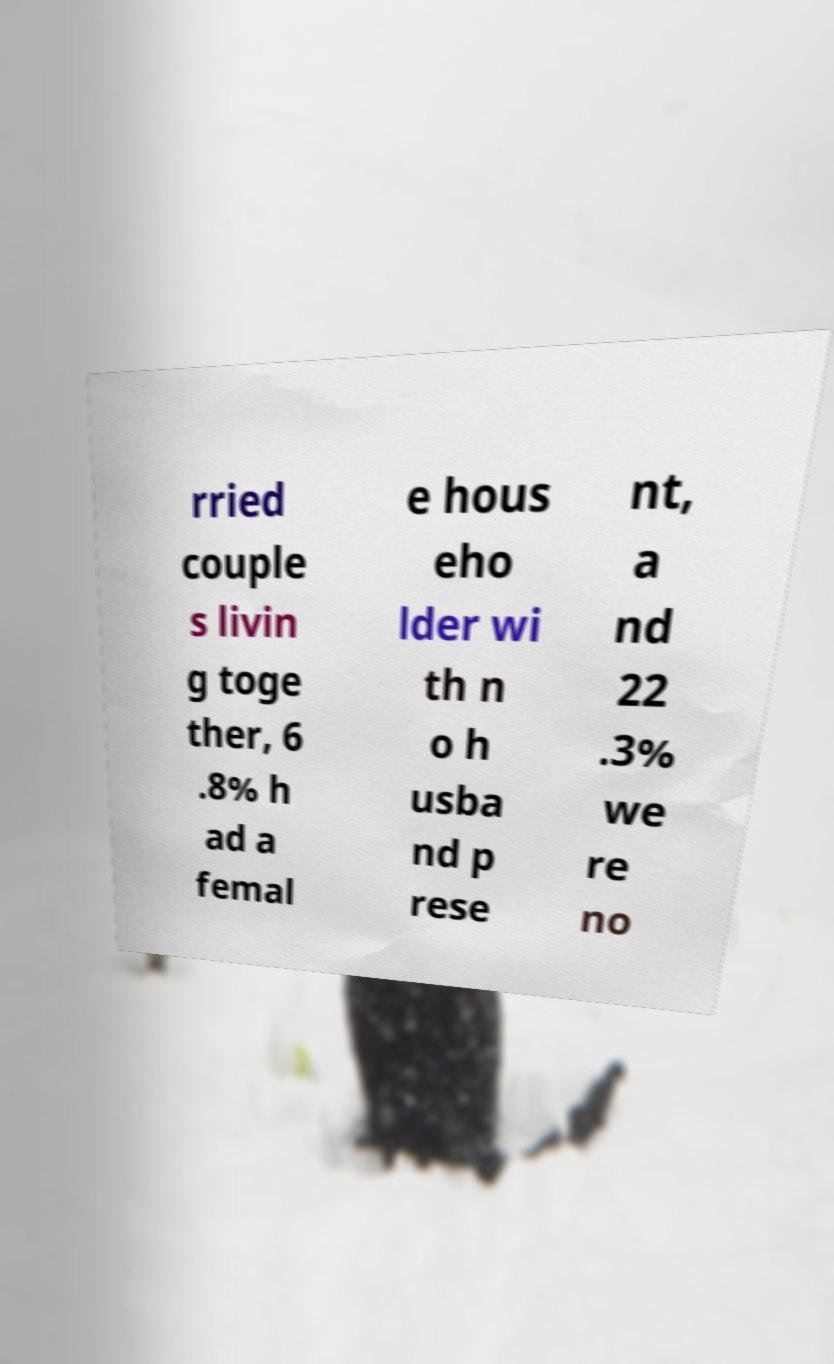Please read and relay the text visible in this image. What does it say? rried couple s livin g toge ther, 6 .8% h ad a femal e hous eho lder wi th n o h usba nd p rese nt, a nd 22 .3% we re no 